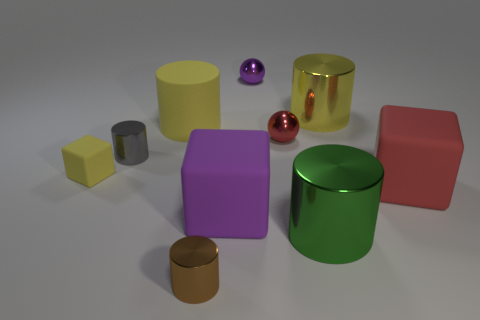Subtract all brown cubes. How many yellow cylinders are left? 2 Subtract all yellow cylinders. How many cylinders are left? 3 Subtract 3 cylinders. How many cylinders are left? 2 Subtract all small shiny cylinders. How many cylinders are left? 3 Subtract all gray cylinders. Subtract all purple balls. How many cylinders are left? 4 Subtract all blocks. How many objects are left? 7 Subtract 0 cyan balls. How many objects are left? 10 Subtract all tiny brown shiny objects. Subtract all gray shiny things. How many objects are left? 8 Add 1 large matte cylinders. How many large matte cylinders are left? 2 Add 7 small green shiny cylinders. How many small green shiny cylinders exist? 7 